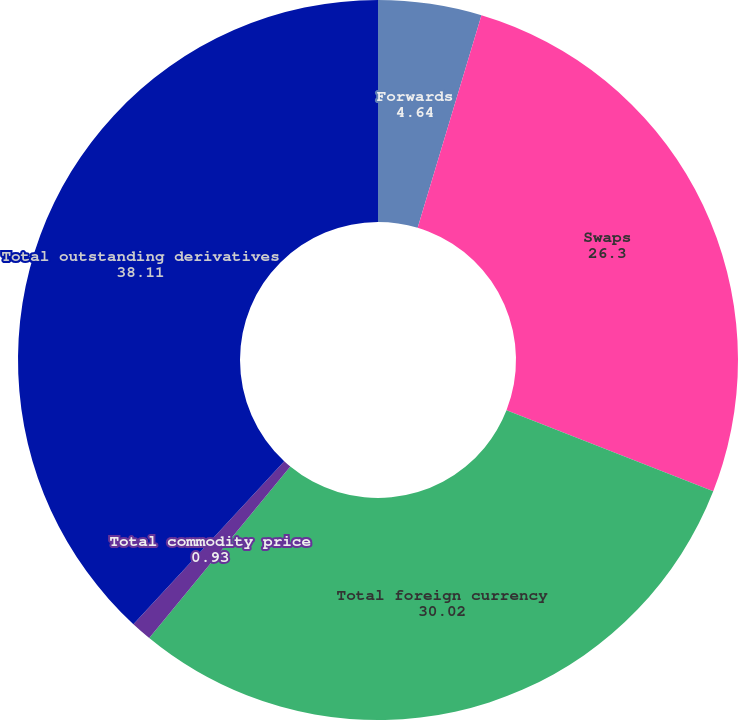Convert chart to OTSL. <chart><loc_0><loc_0><loc_500><loc_500><pie_chart><fcel>Forwards<fcel>Swaps<fcel>Total foreign currency<fcel>Total commodity price<fcel>Total outstanding derivatives<nl><fcel>4.64%<fcel>26.3%<fcel>30.02%<fcel>0.93%<fcel>38.11%<nl></chart> 